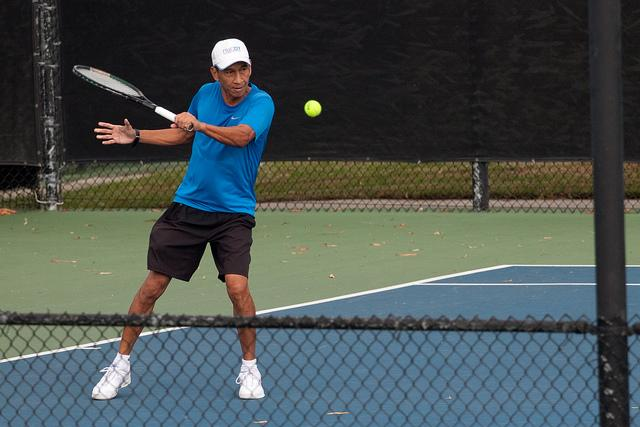What type of shot is this man making? Please explain your reasoning. backhand. The man is hitting a backhand in the tennis match. 